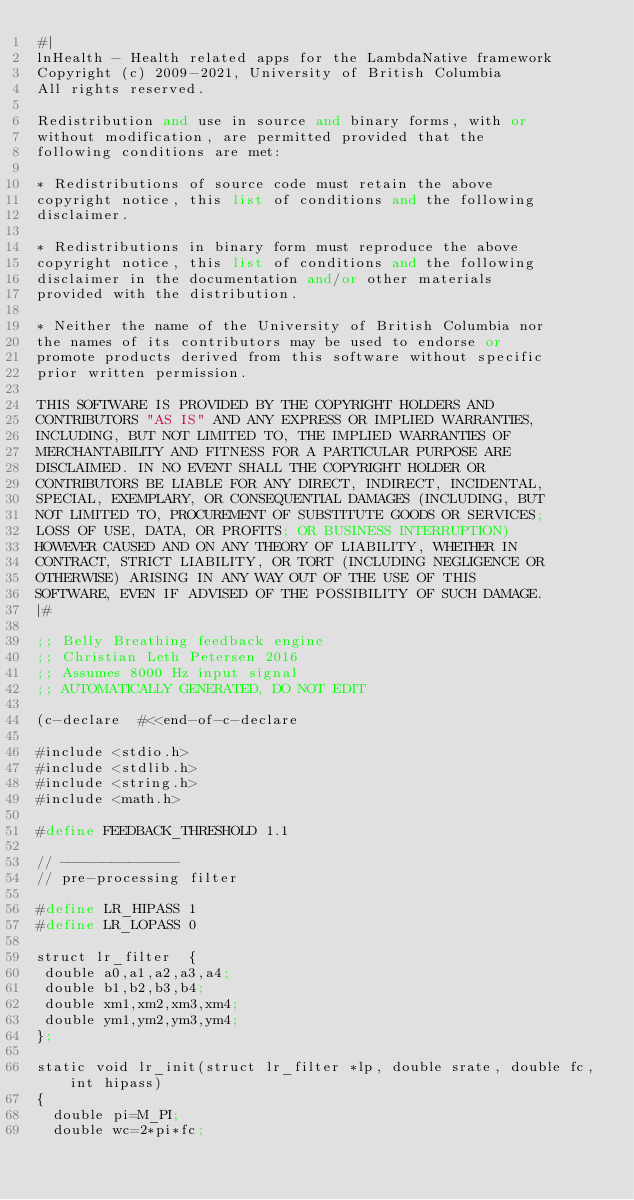Convert code to text. <code><loc_0><loc_0><loc_500><loc_500><_Scheme_>#|
lnHealth - Health related apps for the LambdaNative framework
Copyright (c) 2009-2021, University of British Columbia
All rights reserved.

Redistribution and use in source and binary forms, with or
without modification, are permitted provided that the
following conditions are met:

* Redistributions of source code must retain the above
copyright notice, this list of conditions and the following
disclaimer.

* Redistributions in binary form must reproduce the above
copyright notice, this list of conditions and the following
disclaimer in the documentation and/or other materials
provided with the distribution.

* Neither the name of the University of British Columbia nor
the names of its contributors may be used to endorse or
promote products derived from this software without specific
prior written permission.

THIS SOFTWARE IS PROVIDED BY THE COPYRIGHT HOLDERS AND
CONTRIBUTORS "AS IS" AND ANY EXPRESS OR IMPLIED WARRANTIES,
INCLUDING, BUT NOT LIMITED TO, THE IMPLIED WARRANTIES OF
MERCHANTABILITY AND FITNESS FOR A PARTICULAR PURPOSE ARE
DISCLAIMED. IN NO EVENT SHALL THE COPYRIGHT HOLDER OR
CONTRIBUTORS BE LIABLE FOR ANY DIRECT, INDIRECT, INCIDENTAL,
SPECIAL, EXEMPLARY, OR CONSEQUENTIAL DAMAGES (INCLUDING, BUT
NOT LIMITED TO, PROCUREMENT OF SUBSTITUTE GOODS OR SERVICES;
LOSS OF USE, DATA, OR PROFITS; OR BUSINESS INTERRUPTION)
HOWEVER CAUSED AND ON ANY THEORY OF LIABILITY, WHETHER IN
CONTRACT, STRICT LIABILITY, OR TORT (INCLUDING NEGLIGENCE OR
OTHERWISE) ARISING IN ANY WAY OUT OF THE USE OF THIS
SOFTWARE, EVEN IF ADVISED OF THE POSSIBILITY OF SUCH DAMAGE.
|#

;; Belly Breathing feedback engine
;; Christian Leth Petersen 2016
;; Assumes 8000 Hz input signal
;; AUTOMATICALLY GENERATED, DO NOT EDIT

(c-declare  #<<end-of-c-declare

#include <stdio.h>
#include <stdlib.h>
#include <string.h>
#include <math.h>

#define FEEDBACK_THRESHOLD 1.1

// --------------
// pre-processing filter

#define LR_HIPASS 1
#define LR_LOPASS 0

struct lr_filter  {
 double a0,a1,a2,a3,a4;
 double b1,b2,b3,b4;
 double xm1,xm2,xm3,xm4;
 double ym1,ym2,ym3,ym4;
};

static void lr_init(struct lr_filter *lp, double srate, double fc,int hipass)
{
  double pi=M_PI;
  double wc=2*pi*fc;</code> 